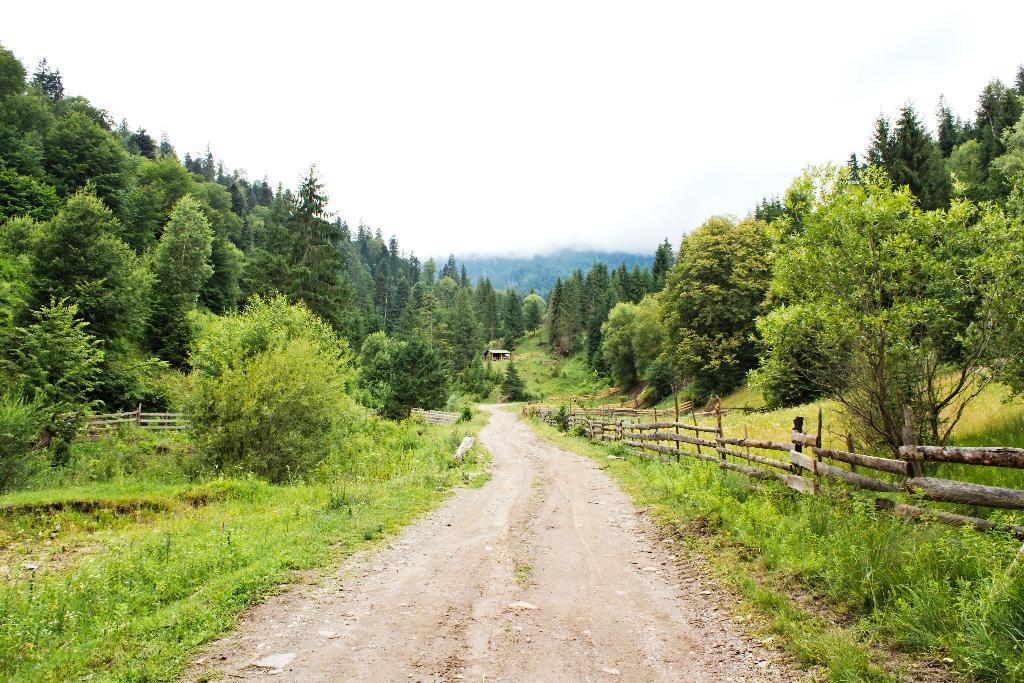What type of road is in the middle of the image? There is a mud road in the middle of the image. What can be seen in the background of the image? There are tall trees in the background of the image. How are the trees arranged in relation to each other? The trees are arranged one beside the other. What is located on the right side of the road? There is a wooden fence on the right side of the road. What type of calculator can be seen on the wooden fence in the image? There is no calculator present in the image; it features a mud road, tall trees, and a wooden fence. What type of ring can be seen on the trees in the image? There are no rings visible on the trees in the image. 